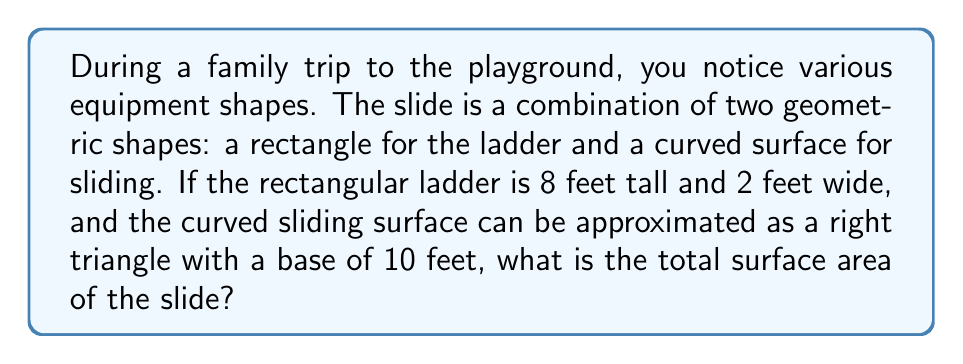Teach me how to tackle this problem. Let's break this problem down step-by-step:

1. Calculate the area of the rectangular ladder:
   $$ A_{rectangle} = length \times width $$
   $$ A_{rectangle} = 8 \text{ ft} \times 2 \text{ ft} = 16 \text{ sq ft} $$

2. For the sliding surface, we need to calculate the area of a right triangle:
   $$ A_{triangle} = \frac{1}{2} \times base \times height $$

3. We know the base is 10 feet, but we need to find the height using the Pythagorean theorem:
   $$ a^2 + b^2 = c^2 $$
   $$ 8^2 + 10^2 = c^2 $$
   $$ 64 + 100 = c^2 $$
   $$ 164 = c^2 $$
   $$ c = \sqrt{164} \approx 12.8 \text{ ft} $$

4. Now we can calculate the area of the triangle:
   $$ A_{triangle} = \frac{1}{2} \times 10 \text{ ft} \times 12.8 \text{ ft} = 64 \text{ sq ft} $$

5. The total surface area is the sum of the rectangle and triangle areas:
   $$ A_{total} = A_{rectangle} + A_{triangle} $$
   $$ A_{total} = 16 \text{ sq ft} + 64 \text{ sq ft} = 80 \text{ sq ft} $$

Therefore, the total surface area of the slide is approximately 80 square feet.
Answer: 80 sq ft 